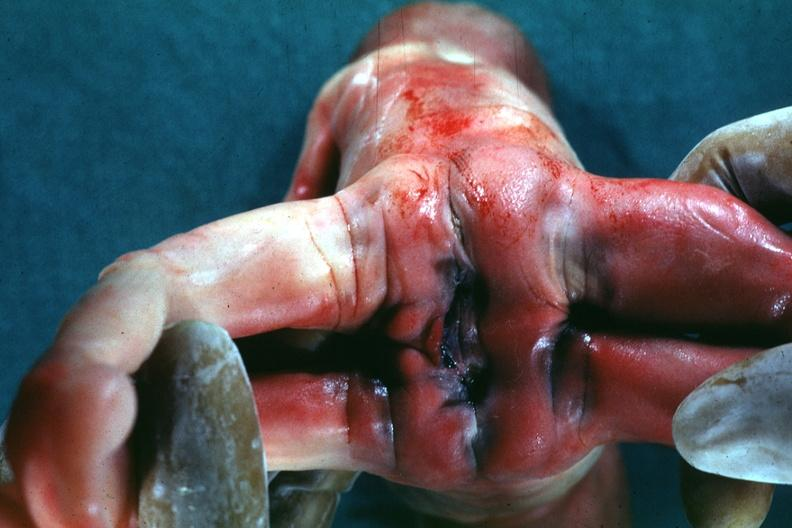s siamese twins present?
Answer the question using a single word or phrase. Yes 